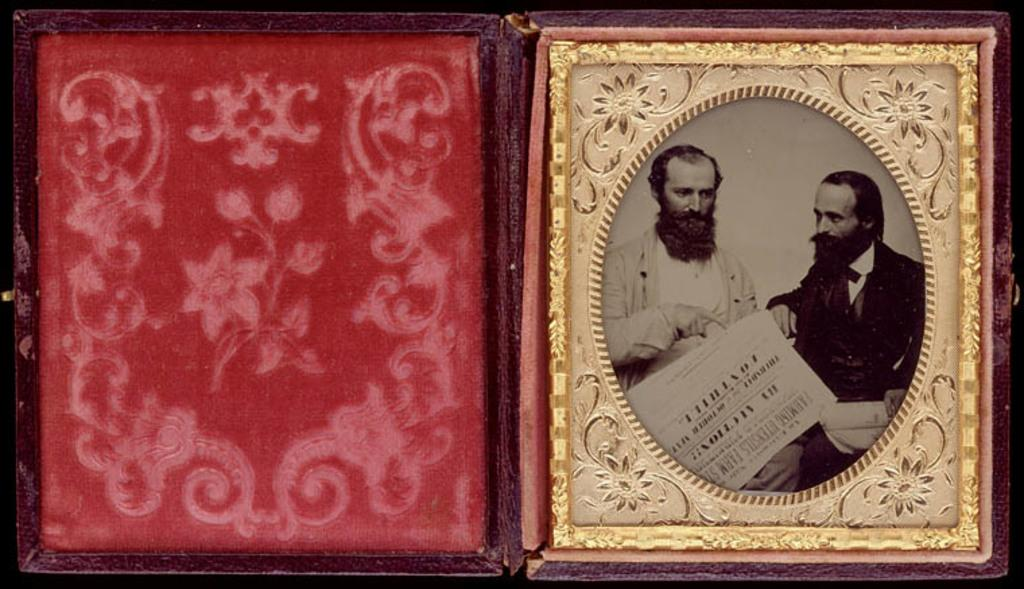How many photo frames are visible in the image? There are two photo frames in the image. What type of doctor is standing next to the photo frames in the image? There is no doctor present in the image; it only features two photo frames. What acoustics can be heard coming from the photo frames in the image? Photo frames do not produce sound, so there are no acoustics to be heard from them in the image. 